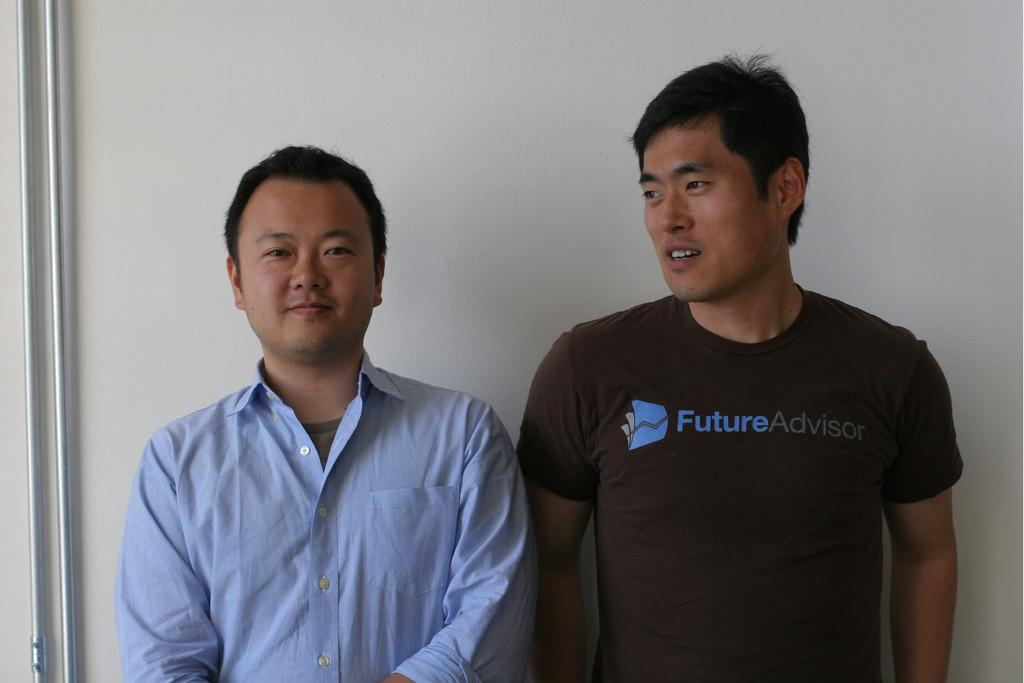How many people are in the image? There are two persons in the image. What are the persons doing in the image? The persons are standing and smiling. What can be seen in the background of the image? There is a wall in the background of the image. What is attached to the wall? There are pipes on the wall. What type of owl can be seen perched on the pipes in the image? There is no owl present in the image; it only features two persons standing and smiling, with pipes on the wall in the background. What material are the pipes made of in the image? The provided facts do not specify the material of the pipes, so we cannot determine if they are made of steel or any other material. 